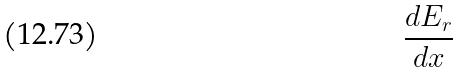<formula> <loc_0><loc_0><loc_500><loc_500>\frac { d E _ { r } } { d x }</formula> 